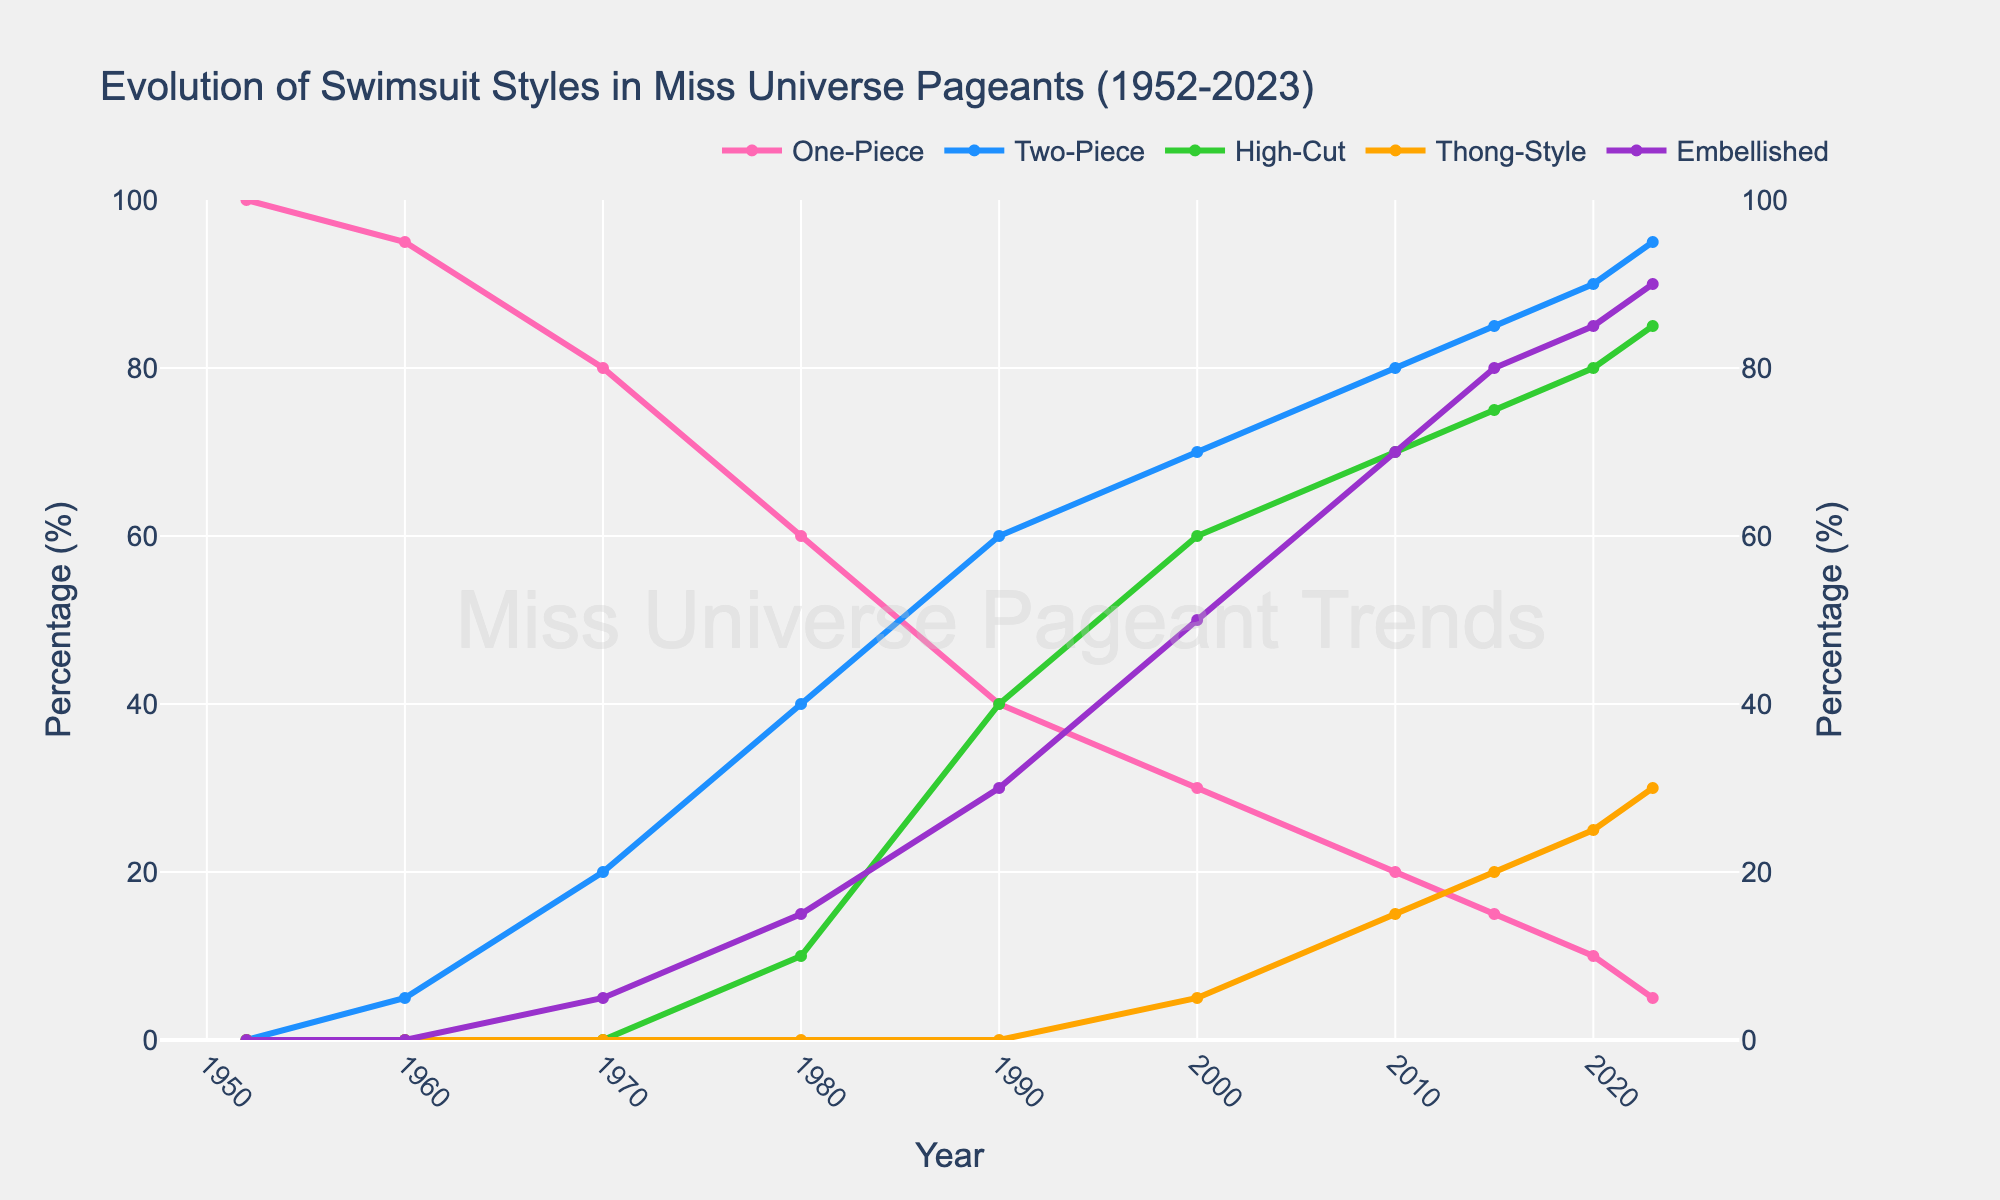What percentage of contestants wore one-piece swimsuits in 1980 compared to 2023? In 1980, 60% of contestants wore one-piece swimsuits. By 2023, this percentage had decreased to 5%. Therefore, the percentage of contestants wearing one-piece swimsuits dropped by 55% from 1980 to 2023.
Answer: 55% How did the popularity of two-piece swimsuits change from 1960 to 2020? In 1960, 5% of contestants wore two-piece swimsuits. By 2020, this number increased to 90%. The increase in popularity is calculated as 90% - 5% = 85%.
Answer: Increased by 85% What is the total percentage of contestants wearing high-cut designs and thong-style bottoms in 2010? In 2010, 70% of contestants wore high-cut designs, and 15% wore thong-style bottoms. Adding these two percentages, 70% + 15% = 85%.
Answer: 85% Compare the trend of high-cut designs and embellished swimwear from 1990 to 2015. Which saw a more significant increase? In 1990, high-cut designs were at 40% and increased to 75% by 2015 (an increase of 35%). Embellished swimwear went from 30% in 1990 to 80% in 2015 (an increase of 50%). Embellished swimwear saw a more significant increase.
Answer: Embellished swimwear Which swimsuit style showed a consistent increase from 1952 to 2023? The two-piece swimsuit style showed a consistent increase from 0% in 1952 to 95% in 2023.
Answer: Two-piece In what year did the percentage of high-cut designs first become equal to or exceed 50%? The percentage of high-cut designs first became equal to or exceeded 50% in the year 2000, with 60%.
Answer: 2000 How did the percentage of contestants wearing thong-style bottoms evolve from 2000 to 2023? In 2000, 5% of contestants wore thong-style bottoms. By 2023, this percentage increased to 30%. The change can be calculated as 30% - 5% = 25%.
Answer: Increased by 25% By how much did the popularity of embellished swimwear increase from 1970 to 2023? In 1970, 5% of contestants wore embellished swimwear. By 2023, this percentage increased to 90%. The increase in popularity is 90% - 5% = 85%.
Answer: 85% What swimsuit style started emerging in popularity after 1980 based on the trends shown? High-cut designs started emerging in popularity after 1980, with a noticeable increase from 10% in 1980 to 40% in 1990.
Answer: High-cut designs Between which consecutive decades did one-piece swimsuits see the largest decrease in popularity? One-piece swimsuits saw the largest decrease between the 1970s (80%) and the 1980s (60%), a decrease of 20%.
Answer: 1970s to 1980s 